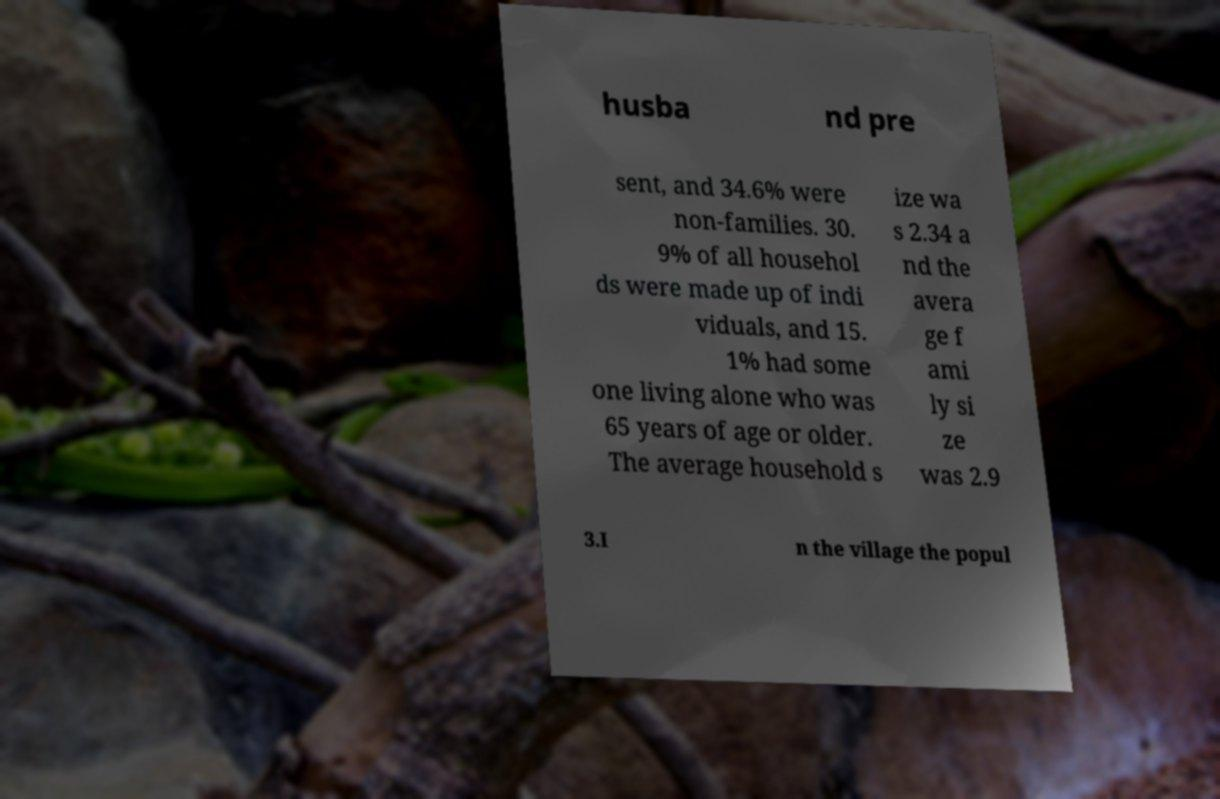Please identify and transcribe the text found in this image. husba nd pre sent, and 34.6% were non-families. 30. 9% of all househol ds were made up of indi viduals, and 15. 1% had some one living alone who was 65 years of age or older. The average household s ize wa s 2.34 a nd the avera ge f ami ly si ze was 2.9 3.I n the village the popul 